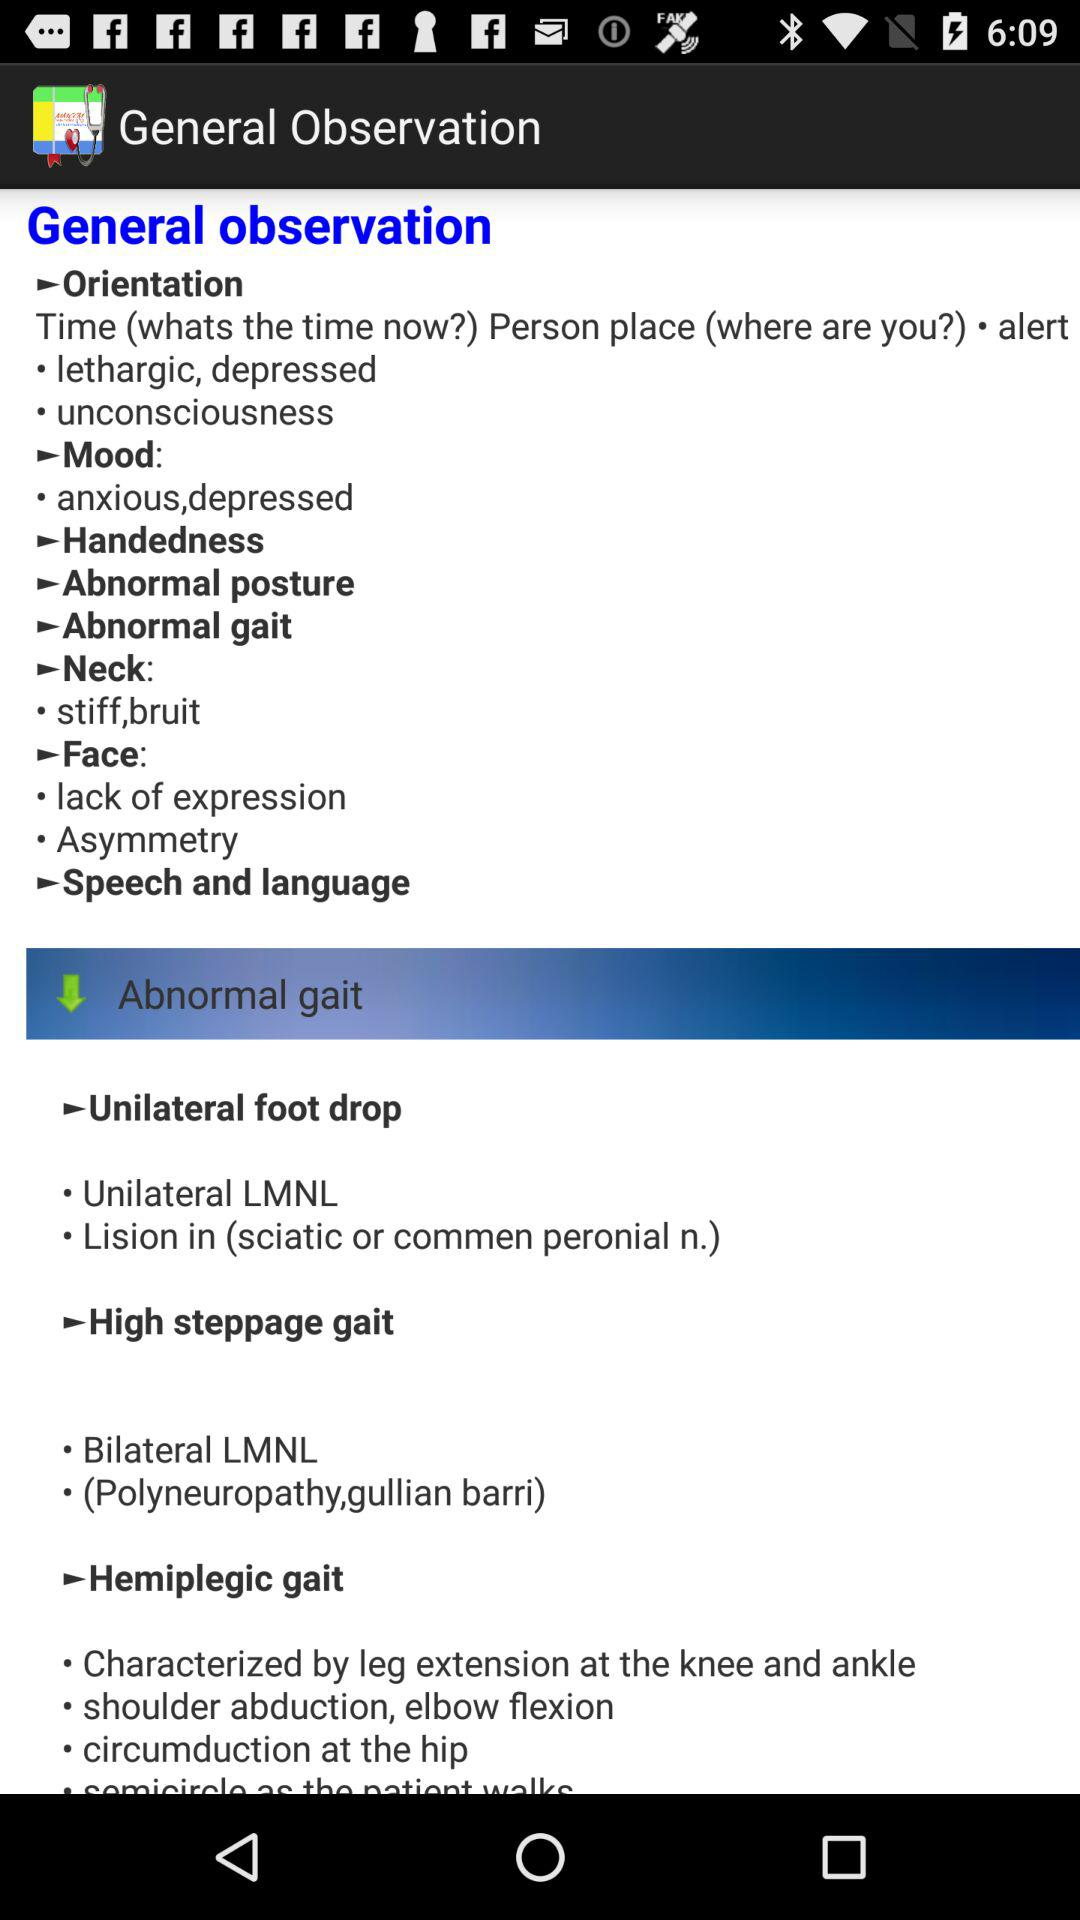What is the application name? The application name is "General Observation". 